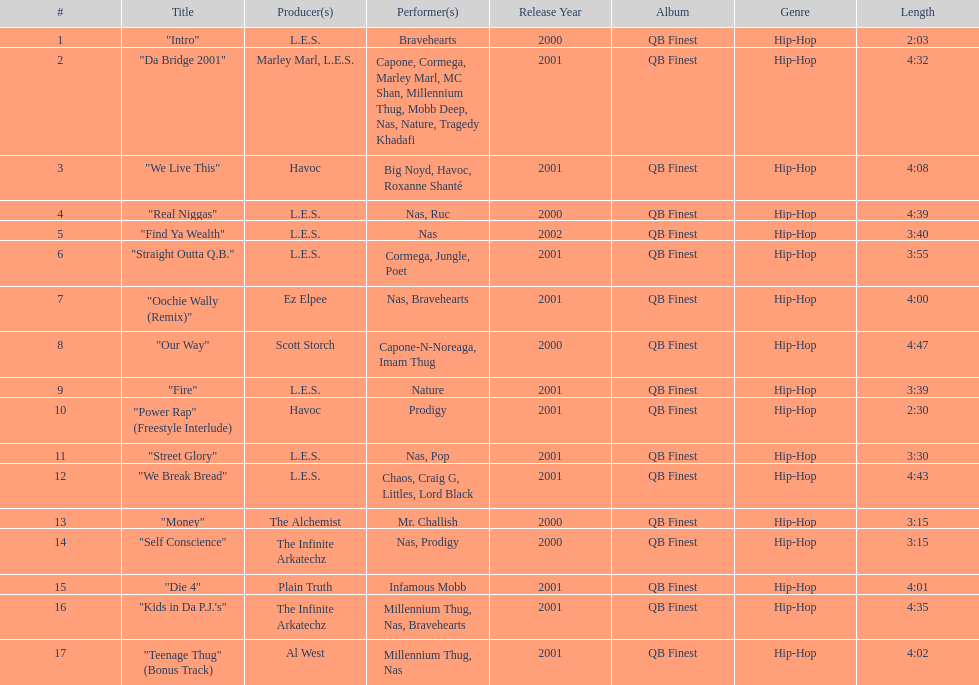Could you parse the entire table? {'header': ['#', 'Title', 'Producer(s)', 'Performer(s)', 'Release Year', 'Album', 'Genre', 'Length'], 'rows': [['1', '"Intro"', 'L.E.S.', 'Bravehearts', '2000', 'QB Finest', 'Hip-Hop', '2:03'], ['2', '"Da Bridge 2001"', 'Marley Marl, L.E.S.', 'Capone, Cormega, Marley Marl, MC Shan, Millennium Thug, Mobb Deep, Nas, Nature, Tragedy Khadafi', '2001', 'QB Finest', 'Hip-Hop', '4:32'], ['3', '"We Live This"', 'Havoc', 'Big Noyd, Havoc, Roxanne Shanté', '2001', 'QB Finest', 'Hip-Hop', '4:08'], ['4', '"Real Niggas"', 'L.E.S.', 'Nas, Ruc', '2000', 'QB Finest', 'Hip-Hop', '4:39'], ['5', '"Find Ya Wealth"', 'L.E.S.', 'Nas', '2002', 'QB Finest', 'Hip-Hop', '3:40'], ['6', '"Straight Outta Q.B."', 'L.E.S.', 'Cormega, Jungle, Poet', '2001', 'QB Finest', 'Hip-Hop', '3:55'], ['7', '"Oochie Wally (Remix)"', 'Ez Elpee', 'Nas, Bravehearts', '2001', 'QB Finest', 'Hip-Hop', '4:00'], ['8', '"Our Way"', 'Scott Storch', 'Capone-N-Noreaga, Imam Thug', '2000', 'QB Finest', 'Hip-Hop', '4:47'], ['9', '"Fire"', 'L.E.S.', 'Nature', '2001', 'QB Finest', 'Hip-Hop', '3:39'], ['10', '"Power Rap" (Freestyle Interlude)', 'Havoc', 'Prodigy', '2001', 'QB Finest', 'Hip-Hop', '2:30'], ['11', '"Street Glory"', 'L.E.S.', 'Nas, Pop', '2001', 'QB Finest', 'Hip-Hop', '3:30'], ['12', '"We Break Bread"', 'L.E.S.', 'Chaos, Craig G, Littles, Lord Black', '2001', 'QB Finest', 'Hip-Hop', '4:43'], ['13', '"Money"', 'The Alchemist', 'Mr. Challish', '2000', 'QB Finest', 'Hip-Hop', '3:15'], ['14', '"Self Conscience"', 'The Infinite Arkatechz', 'Nas, Prodigy', '2000', 'QB Finest', 'Hip-Hop', '3:15'], ['15', '"Die 4"', 'Plain Truth', 'Infamous Mobb', '2001', 'QB Finest', 'Hip-Hop', '4:01'], ['16', '"Kids in Da P.J.\'s"', 'The Infinite Arkatechz', 'Millennium Thug, Nas, Bravehearts', '2001', 'QB Finest', 'Hip-Hop', '4:35'], ['17', '"Teenage Thug" (Bonus Track)', 'Al West', 'Millennium Thug, Nas', '2001', 'QB Finest', 'Hip-Hop', '4:02']]} Which track is longer, "money" or "die 4"? "Die 4". 